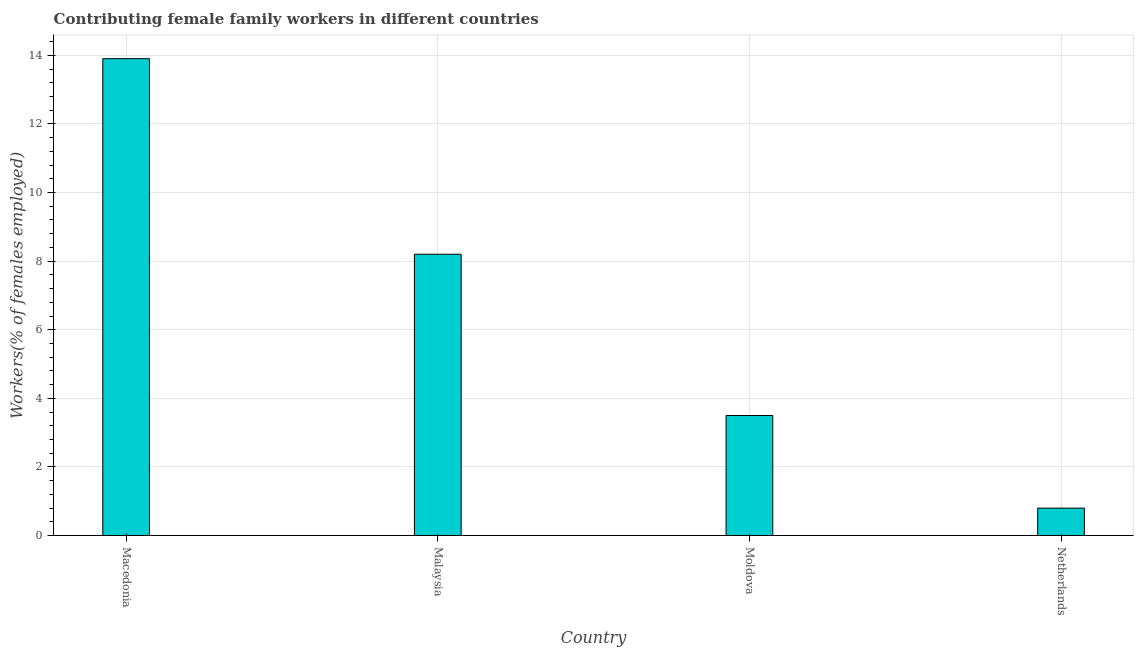Does the graph contain grids?
Give a very brief answer. Yes. What is the title of the graph?
Keep it short and to the point. Contributing female family workers in different countries. What is the label or title of the Y-axis?
Provide a short and direct response. Workers(% of females employed). What is the contributing female family workers in Malaysia?
Your response must be concise. 8.2. Across all countries, what is the maximum contributing female family workers?
Your response must be concise. 13.9. Across all countries, what is the minimum contributing female family workers?
Your answer should be very brief. 0.8. In which country was the contributing female family workers maximum?
Make the answer very short. Macedonia. What is the sum of the contributing female family workers?
Your answer should be compact. 26.4. What is the average contributing female family workers per country?
Give a very brief answer. 6.6. What is the median contributing female family workers?
Give a very brief answer. 5.85. What is the ratio of the contributing female family workers in Macedonia to that in Netherlands?
Keep it short and to the point. 17.38. Is the contributing female family workers in Malaysia less than that in Netherlands?
Offer a very short reply. No. Is the difference between the contributing female family workers in Macedonia and Moldova greater than the difference between any two countries?
Give a very brief answer. No. What is the difference between the highest and the lowest contributing female family workers?
Make the answer very short. 13.1. How many bars are there?
Offer a terse response. 4. How many countries are there in the graph?
Make the answer very short. 4. What is the Workers(% of females employed) of Macedonia?
Ensure brevity in your answer.  13.9. What is the Workers(% of females employed) in Malaysia?
Your answer should be very brief. 8.2. What is the Workers(% of females employed) in Moldova?
Provide a succinct answer. 3.5. What is the Workers(% of females employed) in Netherlands?
Your answer should be very brief. 0.8. What is the difference between the Workers(% of females employed) in Macedonia and Malaysia?
Keep it short and to the point. 5.7. What is the difference between the Workers(% of females employed) in Malaysia and Moldova?
Your answer should be compact. 4.7. What is the ratio of the Workers(% of females employed) in Macedonia to that in Malaysia?
Your answer should be compact. 1.7. What is the ratio of the Workers(% of females employed) in Macedonia to that in Moldova?
Ensure brevity in your answer.  3.97. What is the ratio of the Workers(% of females employed) in Macedonia to that in Netherlands?
Provide a succinct answer. 17.38. What is the ratio of the Workers(% of females employed) in Malaysia to that in Moldova?
Your answer should be compact. 2.34. What is the ratio of the Workers(% of females employed) in Malaysia to that in Netherlands?
Give a very brief answer. 10.25. What is the ratio of the Workers(% of females employed) in Moldova to that in Netherlands?
Ensure brevity in your answer.  4.38. 